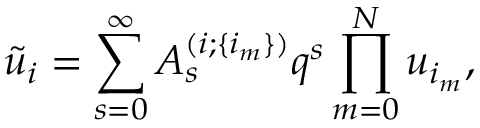<formula> <loc_0><loc_0><loc_500><loc_500>\tilde { u } _ { i } = \sum _ { s = 0 } ^ { \infty } A _ { s } ^ { ( i ; \{ i _ { m } \} ) } q ^ { s } \prod _ { m = 0 } ^ { N } u _ { i _ { m } } ,</formula> 